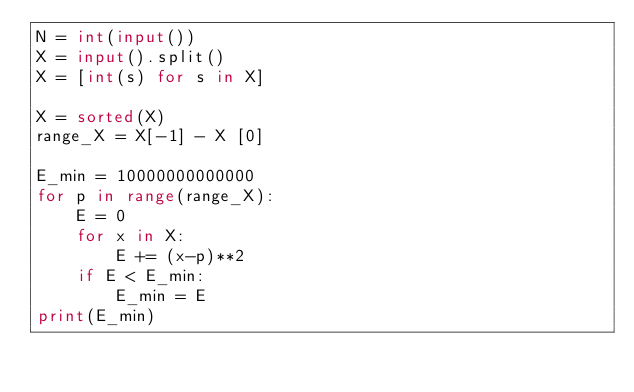<code> <loc_0><loc_0><loc_500><loc_500><_Python_>N = int(input())
X = input().split()
X = [int(s) for s in X]

X = sorted(X)
range_X = X[-1] - X [0]

E_min = 10000000000000
for p in range(range_X):
    E = 0
    for x in X:
        E += (x-p)**2
    if E < E_min:
        E_min = E
print(E_min)</code> 